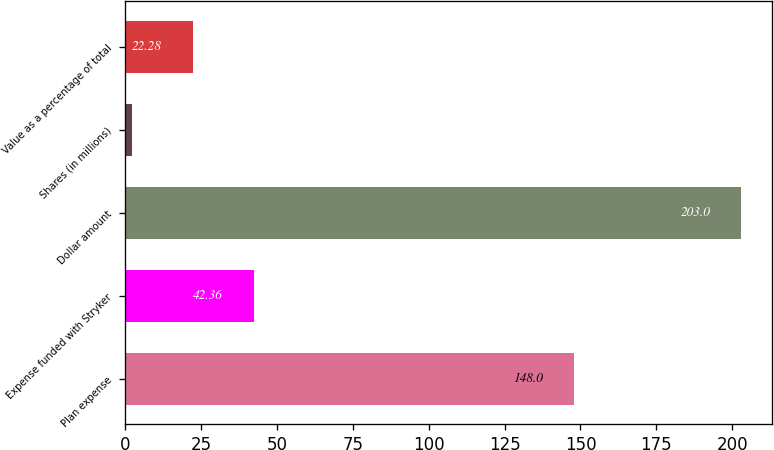<chart> <loc_0><loc_0><loc_500><loc_500><bar_chart><fcel>Plan expense<fcel>Expense funded with Stryker<fcel>Dollar amount<fcel>Shares (in millions)<fcel>Value as a percentage of total<nl><fcel>148<fcel>42.36<fcel>203<fcel>2.2<fcel>22.28<nl></chart> 